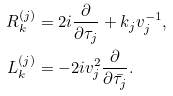Convert formula to latex. <formula><loc_0><loc_0><loc_500><loc_500>R _ { k } ^ { ( j ) } & = 2 i \frac { \partial } { \partial \tau _ { j } } + k _ { j } v _ { j } ^ { - 1 } , \\ L _ { k } ^ { ( j ) } & = - 2 i v _ { j } ^ { 2 } \frac { \partial } { \partial \bar { \tau _ { j } } } .</formula> 